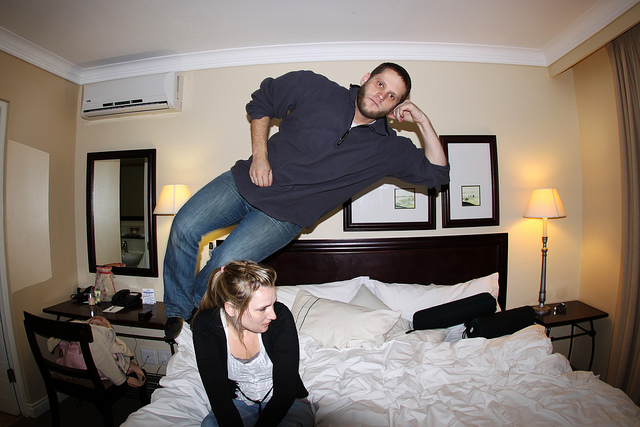How many people can be seen? There are two people in the image; one appears to be floating in mid-air above the bed while the other is sitting on the bed, looking at the floating person with an amused expression. 